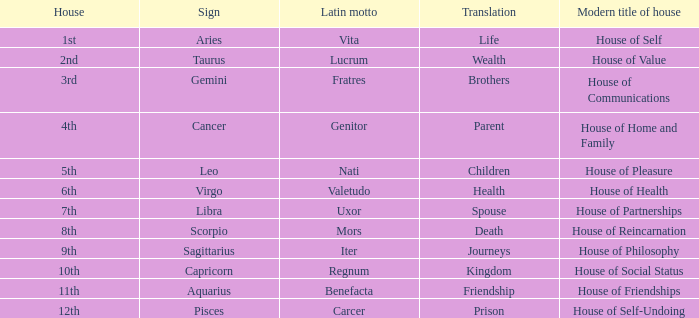What is the translation of the sign of Aquarius? Friendship. 